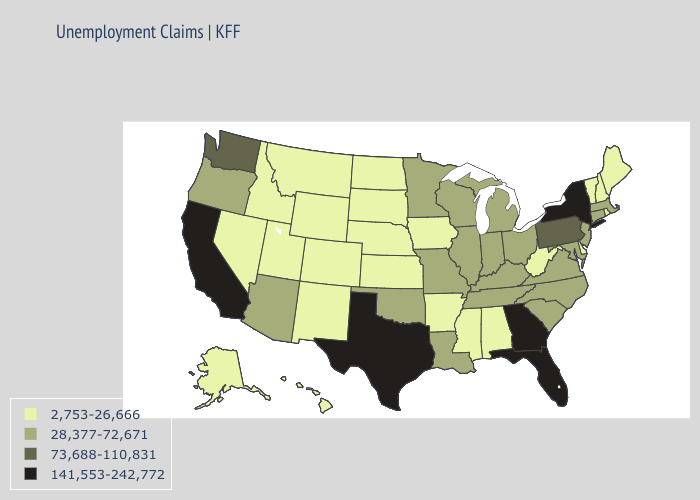What is the highest value in states that border Montana?
Write a very short answer. 2,753-26,666. What is the lowest value in the South?
Give a very brief answer. 2,753-26,666. Among the states that border North Dakota , does Montana have the highest value?
Answer briefly. No. Name the states that have a value in the range 2,753-26,666?
Keep it brief. Alabama, Alaska, Arkansas, Colorado, Delaware, Hawaii, Idaho, Iowa, Kansas, Maine, Mississippi, Montana, Nebraska, Nevada, New Hampshire, New Mexico, North Dakota, Rhode Island, South Dakota, Utah, Vermont, West Virginia, Wyoming. Which states hav the highest value in the MidWest?
Write a very short answer. Illinois, Indiana, Michigan, Minnesota, Missouri, Ohio, Wisconsin. Among the states that border Arkansas , which have the highest value?
Keep it brief. Texas. What is the value of Nevada?
Answer briefly. 2,753-26,666. Which states hav the highest value in the Northeast?
Quick response, please. New York. What is the lowest value in states that border Ohio?
Write a very short answer. 2,753-26,666. Among the states that border Vermont , does Massachusetts have the highest value?
Answer briefly. No. Does New Hampshire have the lowest value in the Northeast?
Quick response, please. Yes. Is the legend a continuous bar?
Concise answer only. No. Which states have the highest value in the USA?
Give a very brief answer. California, Florida, Georgia, New York, Texas. Name the states that have a value in the range 141,553-242,772?
Quick response, please. California, Florida, Georgia, New York, Texas. Which states have the lowest value in the USA?
Answer briefly. Alabama, Alaska, Arkansas, Colorado, Delaware, Hawaii, Idaho, Iowa, Kansas, Maine, Mississippi, Montana, Nebraska, Nevada, New Hampshire, New Mexico, North Dakota, Rhode Island, South Dakota, Utah, Vermont, West Virginia, Wyoming. 